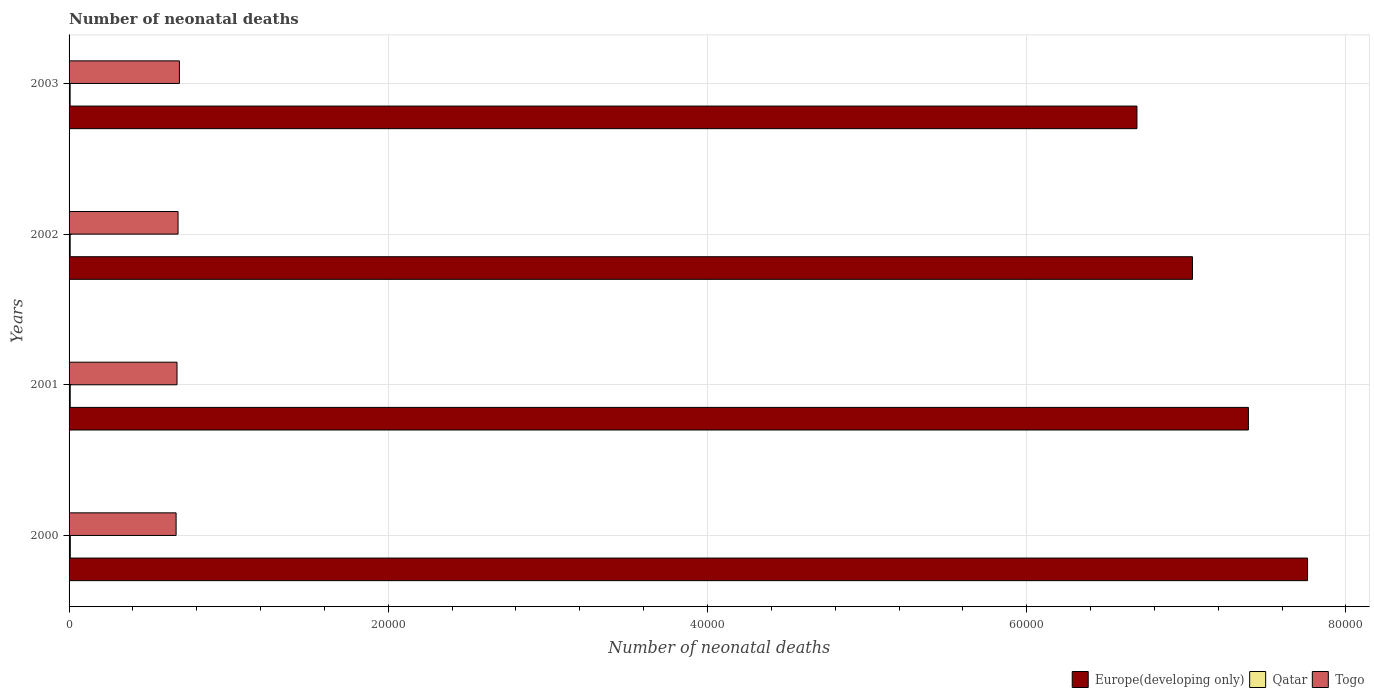Are the number of bars per tick equal to the number of legend labels?
Offer a very short reply. Yes. How many bars are there on the 4th tick from the top?
Provide a short and direct response. 3. What is the number of neonatal deaths in in Togo in 2003?
Ensure brevity in your answer.  6914. Across all years, what is the maximum number of neonatal deaths in in Europe(developing only)?
Make the answer very short. 7.76e+04. Across all years, what is the minimum number of neonatal deaths in in Europe(developing only)?
Your answer should be compact. 6.69e+04. In which year was the number of neonatal deaths in in Qatar maximum?
Give a very brief answer. 2000. In which year was the number of neonatal deaths in in Europe(developing only) minimum?
Your answer should be very brief. 2003. What is the total number of neonatal deaths in in Qatar in the graph?
Provide a short and direct response. 288. What is the difference between the number of neonatal deaths in in Europe(developing only) in 2000 and that in 2001?
Offer a terse response. 3707. What is the difference between the number of neonatal deaths in in Togo in 2001 and the number of neonatal deaths in in Europe(developing only) in 2002?
Offer a terse response. -6.36e+04. What is the average number of neonatal deaths in in Europe(developing only) per year?
Provide a short and direct response. 7.22e+04. In the year 2000, what is the difference between the number of neonatal deaths in in Europe(developing only) and number of neonatal deaths in in Togo?
Provide a succinct answer. 7.09e+04. In how many years, is the number of neonatal deaths in in Togo greater than 52000 ?
Ensure brevity in your answer.  0. What is the ratio of the number of neonatal deaths in in Qatar in 2000 to that in 2002?
Make the answer very short. 1.11. Is the number of neonatal deaths in in Togo in 2002 less than that in 2003?
Provide a short and direct response. Yes. Is the difference between the number of neonatal deaths in in Europe(developing only) in 2001 and 2002 greater than the difference between the number of neonatal deaths in in Togo in 2001 and 2002?
Your answer should be compact. Yes. What is the difference between the highest and the second highest number of neonatal deaths in in Togo?
Ensure brevity in your answer.  86. What is the difference between the highest and the lowest number of neonatal deaths in in Qatar?
Offer a terse response. 11. Is the sum of the number of neonatal deaths in in Europe(developing only) in 2002 and 2003 greater than the maximum number of neonatal deaths in in Qatar across all years?
Keep it short and to the point. Yes. What does the 1st bar from the top in 2001 represents?
Offer a terse response. Togo. What does the 2nd bar from the bottom in 2000 represents?
Ensure brevity in your answer.  Qatar. Is it the case that in every year, the sum of the number of neonatal deaths in in Qatar and number of neonatal deaths in in Europe(developing only) is greater than the number of neonatal deaths in in Togo?
Provide a short and direct response. Yes. Are all the bars in the graph horizontal?
Make the answer very short. Yes. How many years are there in the graph?
Your response must be concise. 4. Where does the legend appear in the graph?
Offer a very short reply. Bottom right. How many legend labels are there?
Make the answer very short. 3. How are the legend labels stacked?
Your answer should be compact. Horizontal. What is the title of the graph?
Provide a short and direct response. Number of neonatal deaths. What is the label or title of the X-axis?
Keep it short and to the point. Number of neonatal deaths. What is the label or title of the Y-axis?
Give a very brief answer. Years. What is the Number of neonatal deaths of Europe(developing only) in 2000?
Provide a succinct answer. 7.76e+04. What is the Number of neonatal deaths in Qatar in 2000?
Ensure brevity in your answer.  78. What is the Number of neonatal deaths of Togo in 2000?
Give a very brief answer. 6706. What is the Number of neonatal deaths of Europe(developing only) in 2001?
Your answer should be compact. 7.39e+04. What is the Number of neonatal deaths in Qatar in 2001?
Provide a short and direct response. 73. What is the Number of neonatal deaths of Togo in 2001?
Keep it short and to the point. 6763. What is the Number of neonatal deaths of Europe(developing only) in 2002?
Your answer should be very brief. 7.04e+04. What is the Number of neonatal deaths in Qatar in 2002?
Offer a very short reply. 70. What is the Number of neonatal deaths of Togo in 2002?
Ensure brevity in your answer.  6828. What is the Number of neonatal deaths of Europe(developing only) in 2003?
Offer a terse response. 6.69e+04. What is the Number of neonatal deaths in Togo in 2003?
Make the answer very short. 6914. Across all years, what is the maximum Number of neonatal deaths in Europe(developing only)?
Offer a very short reply. 7.76e+04. Across all years, what is the maximum Number of neonatal deaths in Togo?
Make the answer very short. 6914. Across all years, what is the minimum Number of neonatal deaths of Europe(developing only)?
Make the answer very short. 6.69e+04. Across all years, what is the minimum Number of neonatal deaths of Qatar?
Offer a very short reply. 67. Across all years, what is the minimum Number of neonatal deaths of Togo?
Your answer should be compact. 6706. What is the total Number of neonatal deaths in Europe(developing only) in the graph?
Keep it short and to the point. 2.89e+05. What is the total Number of neonatal deaths in Qatar in the graph?
Your answer should be very brief. 288. What is the total Number of neonatal deaths of Togo in the graph?
Provide a short and direct response. 2.72e+04. What is the difference between the Number of neonatal deaths of Europe(developing only) in 2000 and that in 2001?
Provide a short and direct response. 3707. What is the difference between the Number of neonatal deaths in Qatar in 2000 and that in 2001?
Give a very brief answer. 5. What is the difference between the Number of neonatal deaths of Togo in 2000 and that in 2001?
Offer a terse response. -57. What is the difference between the Number of neonatal deaths in Europe(developing only) in 2000 and that in 2002?
Offer a very short reply. 7210. What is the difference between the Number of neonatal deaths of Togo in 2000 and that in 2002?
Keep it short and to the point. -122. What is the difference between the Number of neonatal deaths of Europe(developing only) in 2000 and that in 2003?
Your answer should be very brief. 1.07e+04. What is the difference between the Number of neonatal deaths of Togo in 2000 and that in 2003?
Ensure brevity in your answer.  -208. What is the difference between the Number of neonatal deaths of Europe(developing only) in 2001 and that in 2002?
Give a very brief answer. 3503. What is the difference between the Number of neonatal deaths of Qatar in 2001 and that in 2002?
Offer a very short reply. 3. What is the difference between the Number of neonatal deaths in Togo in 2001 and that in 2002?
Provide a short and direct response. -65. What is the difference between the Number of neonatal deaths in Europe(developing only) in 2001 and that in 2003?
Your answer should be very brief. 6982. What is the difference between the Number of neonatal deaths in Qatar in 2001 and that in 2003?
Give a very brief answer. 6. What is the difference between the Number of neonatal deaths of Togo in 2001 and that in 2003?
Provide a short and direct response. -151. What is the difference between the Number of neonatal deaths in Europe(developing only) in 2002 and that in 2003?
Your answer should be compact. 3479. What is the difference between the Number of neonatal deaths in Qatar in 2002 and that in 2003?
Ensure brevity in your answer.  3. What is the difference between the Number of neonatal deaths of Togo in 2002 and that in 2003?
Offer a very short reply. -86. What is the difference between the Number of neonatal deaths of Europe(developing only) in 2000 and the Number of neonatal deaths of Qatar in 2001?
Ensure brevity in your answer.  7.75e+04. What is the difference between the Number of neonatal deaths in Europe(developing only) in 2000 and the Number of neonatal deaths in Togo in 2001?
Your answer should be very brief. 7.08e+04. What is the difference between the Number of neonatal deaths of Qatar in 2000 and the Number of neonatal deaths of Togo in 2001?
Your response must be concise. -6685. What is the difference between the Number of neonatal deaths in Europe(developing only) in 2000 and the Number of neonatal deaths in Qatar in 2002?
Your answer should be very brief. 7.75e+04. What is the difference between the Number of neonatal deaths in Europe(developing only) in 2000 and the Number of neonatal deaths in Togo in 2002?
Give a very brief answer. 7.08e+04. What is the difference between the Number of neonatal deaths of Qatar in 2000 and the Number of neonatal deaths of Togo in 2002?
Ensure brevity in your answer.  -6750. What is the difference between the Number of neonatal deaths in Europe(developing only) in 2000 and the Number of neonatal deaths in Qatar in 2003?
Offer a very short reply. 7.75e+04. What is the difference between the Number of neonatal deaths in Europe(developing only) in 2000 and the Number of neonatal deaths in Togo in 2003?
Offer a very short reply. 7.07e+04. What is the difference between the Number of neonatal deaths of Qatar in 2000 and the Number of neonatal deaths of Togo in 2003?
Offer a very short reply. -6836. What is the difference between the Number of neonatal deaths in Europe(developing only) in 2001 and the Number of neonatal deaths in Qatar in 2002?
Keep it short and to the point. 7.38e+04. What is the difference between the Number of neonatal deaths of Europe(developing only) in 2001 and the Number of neonatal deaths of Togo in 2002?
Make the answer very short. 6.71e+04. What is the difference between the Number of neonatal deaths of Qatar in 2001 and the Number of neonatal deaths of Togo in 2002?
Your answer should be compact. -6755. What is the difference between the Number of neonatal deaths of Europe(developing only) in 2001 and the Number of neonatal deaths of Qatar in 2003?
Your response must be concise. 7.38e+04. What is the difference between the Number of neonatal deaths of Europe(developing only) in 2001 and the Number of neonatal deaths of Togo in 2003?
Your answer should be compact. 6.70e+04. What is the difference between the Number of neonatal deaths in Qatar in 2001 and the Number of neonatal deaths in Togo in 2003?
Your answer should be compact. -6841. What is the difference between the Number of neonatal deaths in Europe(developing only) in 2002 and the Number of neonatal deaths in Qatar in 2003?
Keep it short and to the point. 7.03e+04. What is the difference between the Number of neonatal deaths of Europe(developing only) in 2002 and the Number of neonatal deaths of Togo in 2003?
Make the answer very short. 6.35e+04. What is the difference between the Number of neonatal deaths of Qatar in 2002 and the Number of neonatal deaths of Togo in 2003?
Your answer should be compact. -6844. What is the average Number of neonatal deaths of Europe(developing only) per year?
Keep it short and to the point. 7.22e+04. What is the average Number of neonatal deaths in Togo per year?
Provide a short and direct response. 6802.75. In the year 2000, what is the difference between the Number of neonatal deaths of Europe(developing only) and Number of neonatal deaths of Qatar?
Give a very brief answer. 7.75e+04. In the year 2000, what is the difference between the Number of neonatal deaths of Europe(developing only) and Number of neonatal deaths of Togo?
Keep it short and to the point. 7.09e+04. In the year 2000, what is the difference between the Number of neonatal deaths in Qatar and Number of neonatal deaths in Togo?
Offer a very short reply. -6628. In the year 2001, what is the difference between the Number of neonatal deaths in Europe(developing only) and Number of neonatal deaths in Qatar?
Keep it short and to the point. 7.38e+04. In the year 2001, what is the difference between the Number of neonatal deaths in Europe(developing only) and Number of neonatal deaths in Togo?
Your answer should be compact. 6.71e+04. In the year 2001, what is the difference between the Number of neonatal deaths of Qatar and Number of neonatal deaths of Togo?
Ensure brevity in your answer.  -6690. In the year 2002, what is the difference between the Number of neonatal deaths of Europe(developing only) and Number of neonatal deaths of Qatar?
Your answer should be compact. 7.03e+04. In the year 2002, what is the difference between the Number of neonatal deaths in Europe(developing only) and Number of neonatal deaths in Togo?
Offer a terse response. 6.36e+04. In the year 2002, what is the difference between the Number of neonatal deaths in Qatar and Number of neonatal deaths in Togo?
Offer a very short reply. -6758. In the year 2003, what is the difference between the Number of neonatal deaths in Europe(developing only) and Number of neonatal deaths in Qatar?
Give a very brief answer. 6.68e+04. In the year 2003, what is the difference between the Number of neonatal deaths in Europe(developing only) and Number of neonatal deaths in Togo?
Your response must be concise. 6.00e+04. In the year 2003, what is the difference between the Number of neonatal deaths of Qatar and Number of neonatal deaths of Togo?
Offer a terse response. -6847. What is the ratio of the Number of neonatal deaths in Europe(developing only) in 2000 to that in 2001?
Your answer should be very brief. 1.05. What is the ratio of the Number of neonatal deaths of Qatar in 2000 to that in 2001?
Give a very brief answer. 1.07. What is the ratio of the Number of neonatal deaths in Europe(developing only) in 2000 to that in 2002?
Your response must be concise. 1.1. What is the ratio of the Number of neonatal deaths in Qatar in 2000 to that in 2002?
Keep it short and to the point. 1.11. What is the ratio of the Number of neonatal deaths of Togo in 2000 to that in 2002?
Your response must be concise. 0.98. What is the ratio of the Number of neonatal deaths of Europe(developing only) in 2000 to that in 2003?
Provide a succinct answer. 1.16. What is the ratio of the Number of neonatal deaths in Qatar in 2000 to that in 2003?
Ensure brevity in your answer.  1.16. What is the ratio of the Number of neonatal deaths in Togo in 2000 to that in 2003?
Offer a very short reply. 0.97. What is the ratio of the Number of neonatal deaths in Europe(developing only) in 2001 to that in 2002?
Offer a terse response. 1.05. What is the ratio of the Number of neonatal deaths of Qatar in 2001 to that in 2002?
Provide a succinct answer. 1.04. What is the ratio of the Number of neonatal deaths in Togo in 2001 to that in 2002?
Make the answer very short. 0.99. What is the ratio of the Number of neonatal deaths in Europe(developing only) in 2001 to that in 2003?
Your answer should be very brief. 1.1. What is the ratio of the Number of neonatal deaths in Qatar in 2001 to that in 2003?
Keep it short and to the point. 1.09. What is the ratio of the Number of neonatal deaths in Togo in 2001 to that in 2003?
Offer a very short reply. 0.98. What is the ratio of the Number of neonatal deaths in Europe(developing only) in 2002 to that in 2003?
Your answer should be compact. 1.05. What is the ratio of the Number of neonatal deaths in Qatar in 2002 to that in 2003?
Offer a terse response. 1.04. What is the ratio of the Number of neonatal deaths in Togo in 2002 to that in 2003?
Ensure brevity in your answer.  0.99. What is the difference between the highest and the second highest Number of neonatal deaths of Europe(developing only)?
Provide a short and direct response. 3707. What is the difference between the highest and the second highest Number of neonatal deaths in Togo?
Your response must be concise. 86. What is the difference between the highest and the lowest Number of neonatal deaths in Europe(developing only)?
Provide a succinct answer. 1.07e+04. What is the difference between the highest and the lowest Number of neonatal deaths of Togo?
Offer a terse response. 208. 